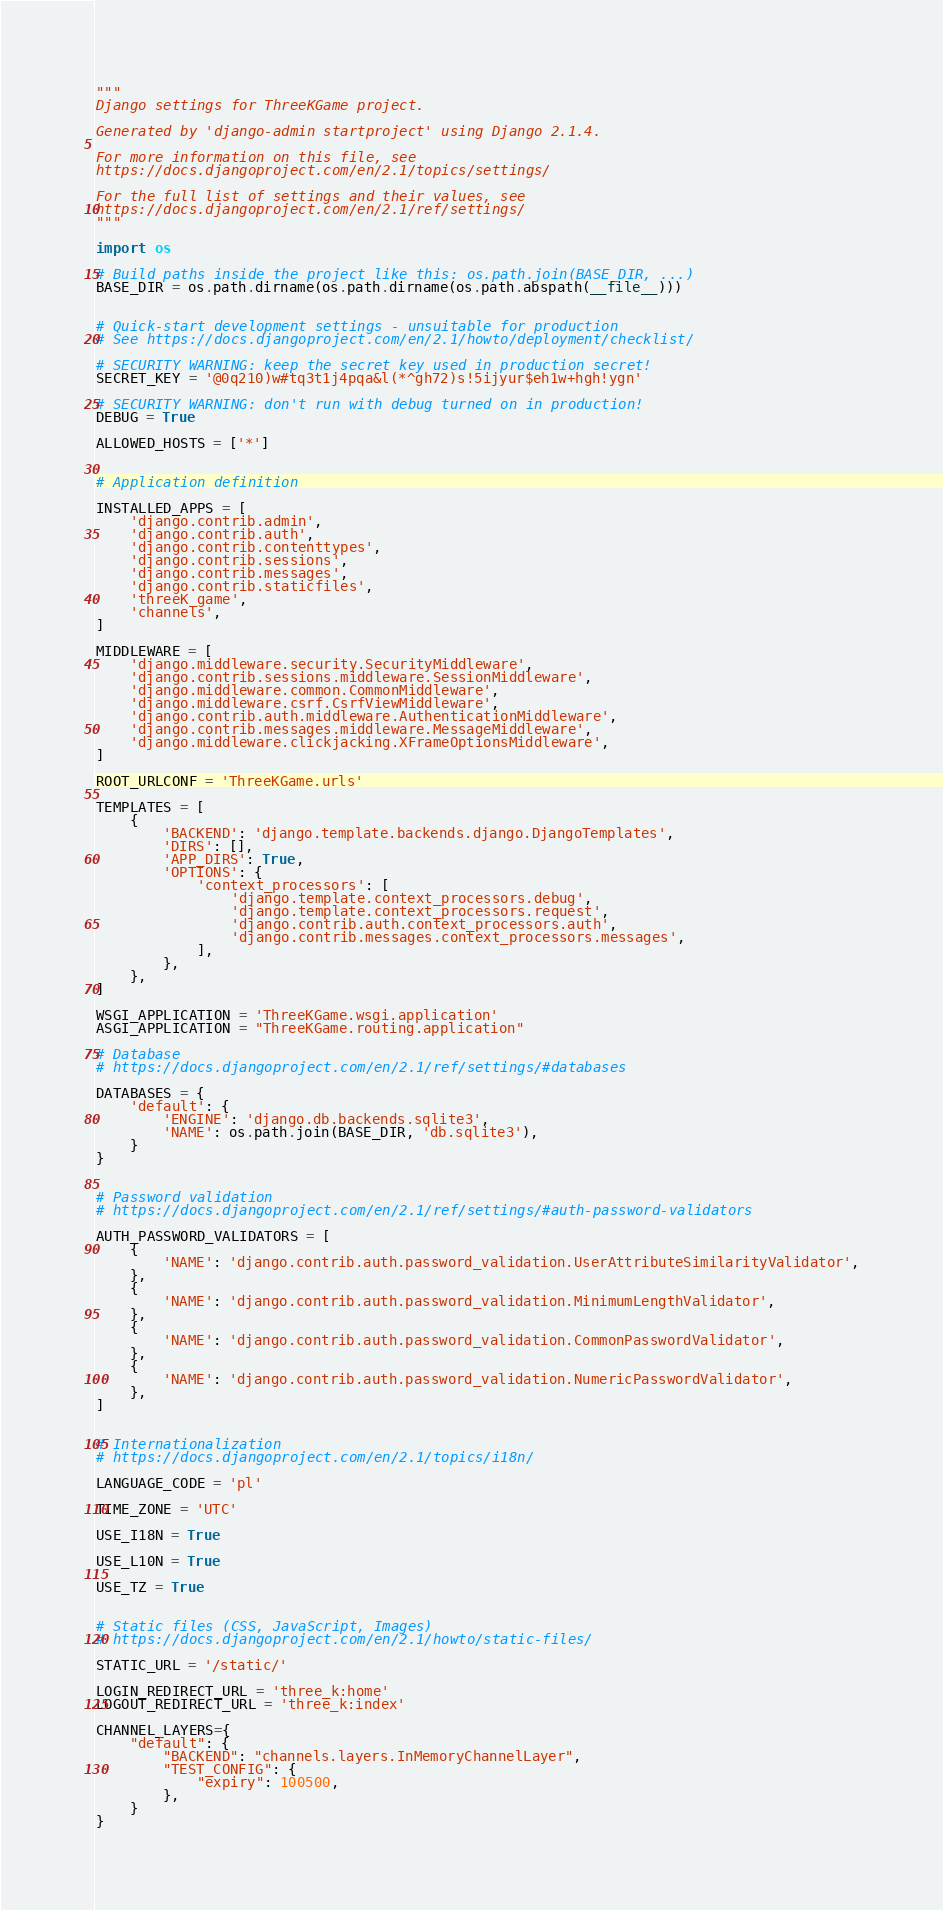<code> <loc_0><loc_0><loc_500><loc_500><_Python_>"""
Django settings for ThreeKGame project.

Generated by 'django-admin startproject' using Django 2.1.4.

For more information on this file, see
https://docs.djangoproject.com/en/2.1/topics/settings/

For the full list of settings and their values, see
https://docs.djangoproject.com/en/2.1/ref/settings/
"""

import os

# Build paths inside the project like this: os.path.join(BASE_DIR, ...)
BASE_DIR = os.path.dirname(os.path.dirname(os.path.abspath(__file__)))


# Quick-start development settings - unsuitable for production
# See https://docs.djangoproject.com/en/2.1/howto/deployment/checklist/

# SECURITY WARNING: keep the secret key used in production secret!
SECRET_KEY = '@0q210)w#tq3t1j4pqa&l(*^gh72)s!5ijyur$eh1w+hgh!ygn'

# SECURITY WARNING: don't run with debug turned on in production!
DEBUG = True

ALLOWED_HOSTS = ['*']


# Application definition

INSTALLED_APPS = [
    'django.contrib.admin',
    'django.contrib.auth',
    'django.contrib.contenttypes',
    'django.contrib.sessions',
    'django.contrib.messages',
    'django.contrib.staticfiles',
    'threeK_game',
    'channels',
]

MIDDLEWARE = [
    'django.middleware.security.SecurityMiddleware',
    'django.contrib.sessions.middleware.SessionMiddleware',
    'django.middleware.common.CommonMiddleware',
    'django.middleware.csrf.CsrfViewMiddleware',
    'django.contrib.auth.middleware.AuthenticationMiddleware',
    'django.contrib.messages.middleware.MessageMiddleware',
    'django.middleware.clickjacking.XFrameOptionsMiddleware',
]

ROOT_URLCONF = 'ThreeKGame.urls'

TEMPLATES = [
    {
        'BACKEND': 'django.template.backends.django.DjangoTemplates',
        'DIRS': [],
        'APP_DIRS': True,
        'OPTIONS': {
            'context_processors': [
                'django.template.context_processors.debug',
                'django.template.context_processors.request',
                'django.contrib.auth.context_processors.auth',
                'django.contrib.messages.context_processors.messages',
            ],
        },
    },
]

WSGI_APPLICATION = 'ThreeKGame.wsgi.application'
ASGI_APPLICATION = "ThreeKGame.routing.application"

# Database
# https://docs.djangoproject.com/en/2.1/ref/settings/#databases

DATABASES = {
    'default': {
        'ENGINE': 'django.db.backends.sqlite3',
        'NAME': os.path.join(BASE_DIR, 'db.sqlite3'),
    }
}


# Password validation
# https://docs.djangoproject.com/en/2.1/ref/settings/#auth-password-validators

AUTH_PASSWORD_VALIDATORS = [
    {
        'NAME': 'django.contrib.auth.password_validation.UserAttributeSimilarityValidator',
    },
    {
        'NAME': 'django.contrib.auth.password_validation.MinimumLengthValidator',
    },
    {
        'NAME': 'django.contrib.auth.password_validation.CommonPasswordValidator',
    },
    {
        'NAME': 'django.contrib.auth.password_validation.NumericPasswordValidator',
    },
]


# Internationalization
# https://docs.djangoproject.com/en/2.1/topics/i18n/

LANGUAGE_CODE = 'pl'

TIME_ZONE = 'UTC'

USE_I18N = True

USE_L10N = True

USE_TZ = True


# Static files (CSS, JavaScript, Images)
# https://docs.djangoproject.com/en/2.1/howto/static-files/

STATIC_URL = '/static/'

LOGIN_REDIRECT_URL = 'three_k:home'
LOGOUT_REDIRECT_URL = 'three_k:index'

CHANNEL_LAYERS={ 
    "default": { 
        "BACKEND": "channels.layers.InMemoryChannelLayer",
        "TEST_CONFIG": { 
            "expiry": 100500, 
        }, 
    }
} </code> 